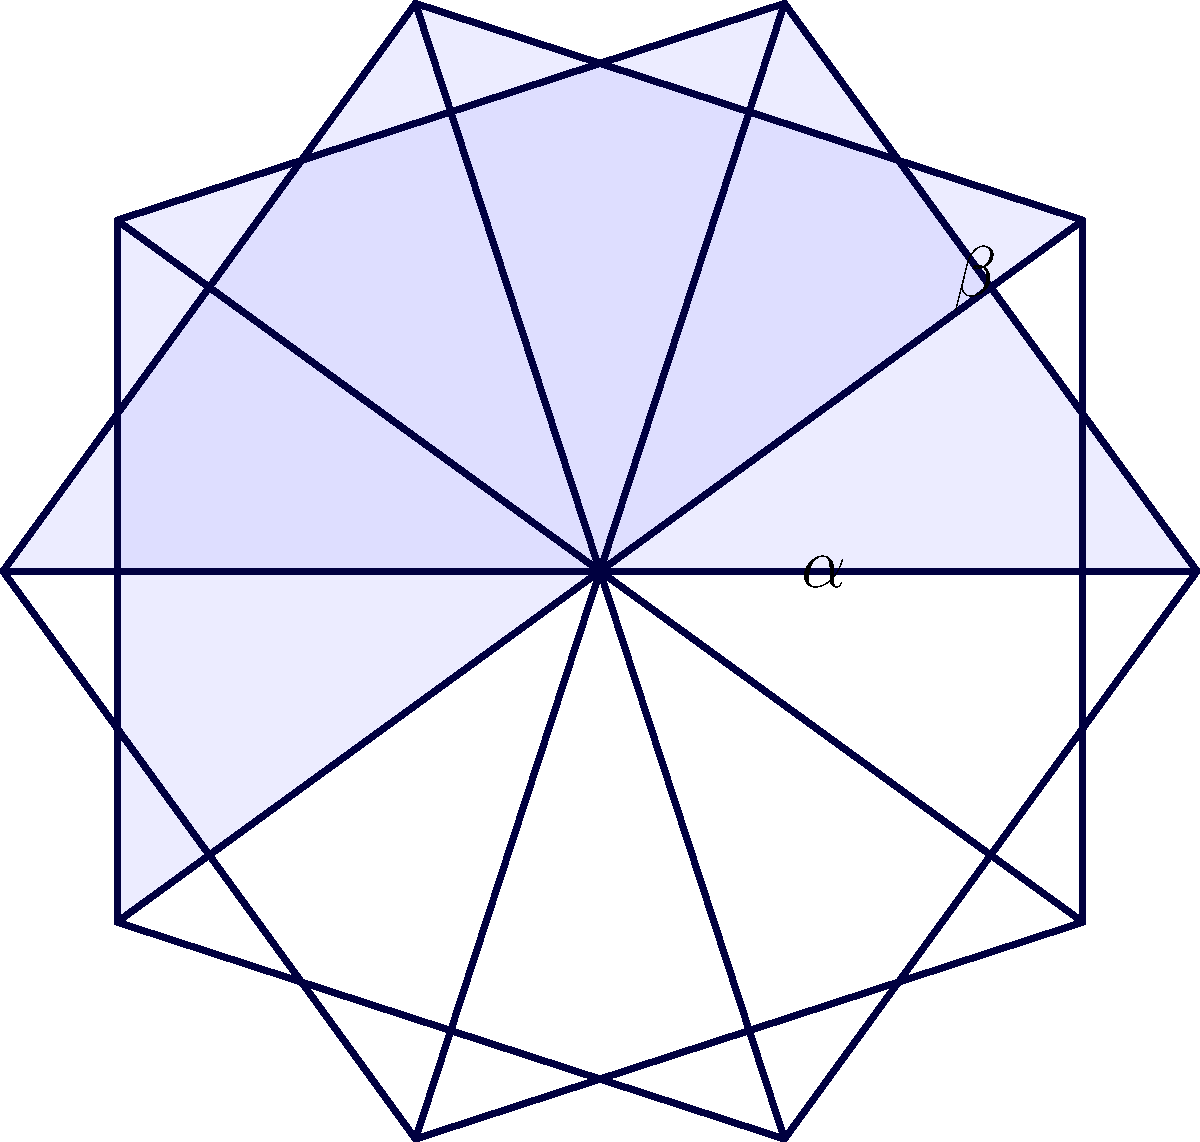In this Islamic geometric star pattern, angle $\alpha$ represents the central angle of each small triangle, and angle $\beta$ represents the angle between two adjacent star points. If the star has 10 points, what is the relationship between $\alpha$ and $\beta$? Let's approach this step-by-step:

1) First, note that the star has 10 points, which means it has rotational symmetry of order 10.

2) The full circle (360°) is divided into 10 equal parts, so each central angle (angle $\alpha$) is:
   $$\alpha = \frac{360°}{10} = 36°$$

3) Now, let's consider angle $\beta$. It's an exterior angle of the star.

4) In a regular star polygon, the number of points (n) and the step size (k) are related. For a 10-pointed star, k = 3.

5) The formula for the exterior angle of a regular star polygon is:
   $$\beta = \frac{k \cdot 360°}{n} = \frac{3 \cdot 360°}{10} = 108°$$

6) We can see that:
   $$\beta = 3\alpha$$

7) This relationship holds true for all 10-pointed stars in Islamic geometric patterns.
Answer: $\beta = 3\alpha$ 